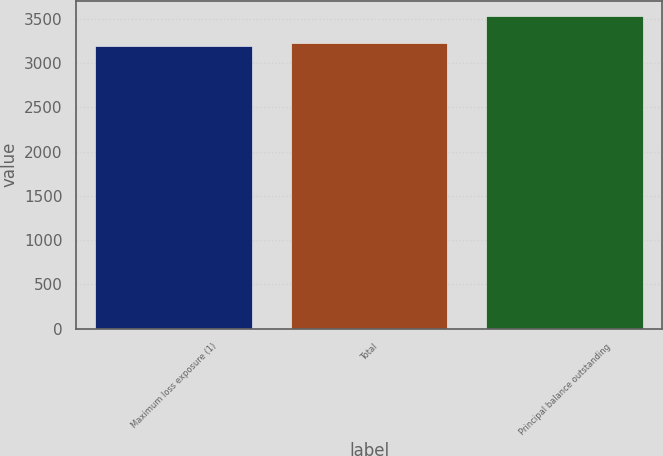Convert chart to OTSL. <chart><loc_0><loc_0><loc_500><loc_500><bar_chart><fcel>Maximum loss exposure (1)<fcel>Total<fcel>Principal balance outstanding<nl><fcel>3192<fcel>3225.7<fcel>3529<nl></chart> 